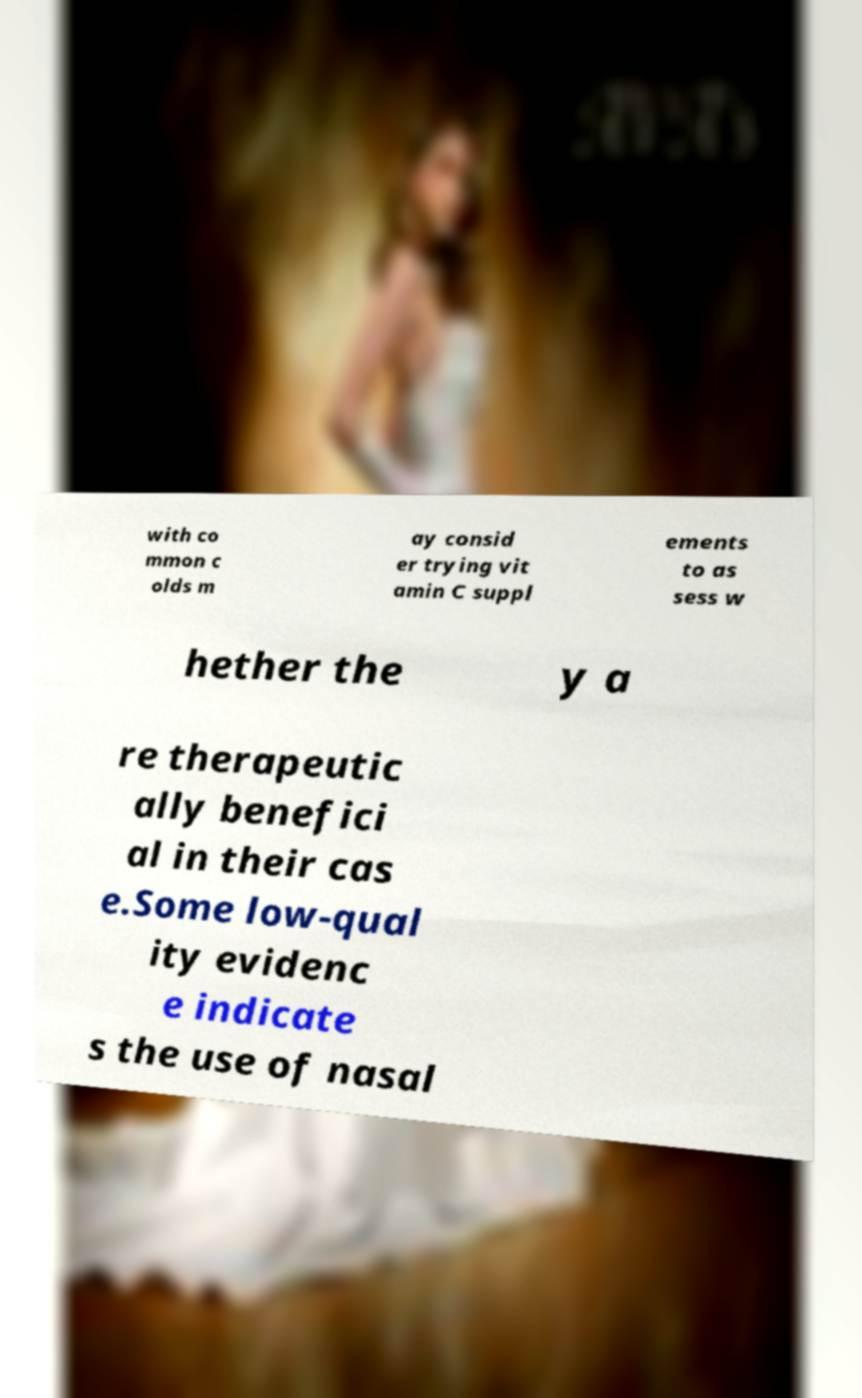Could you extract and type out the text from this image? with co mmon c olds m ay consid er trying vit amin C suppl ements to as sess w hether the y a re therapeutic ally benefici al in their cas e.Some low-qual ity evidenc e indicate s the use of nasal 